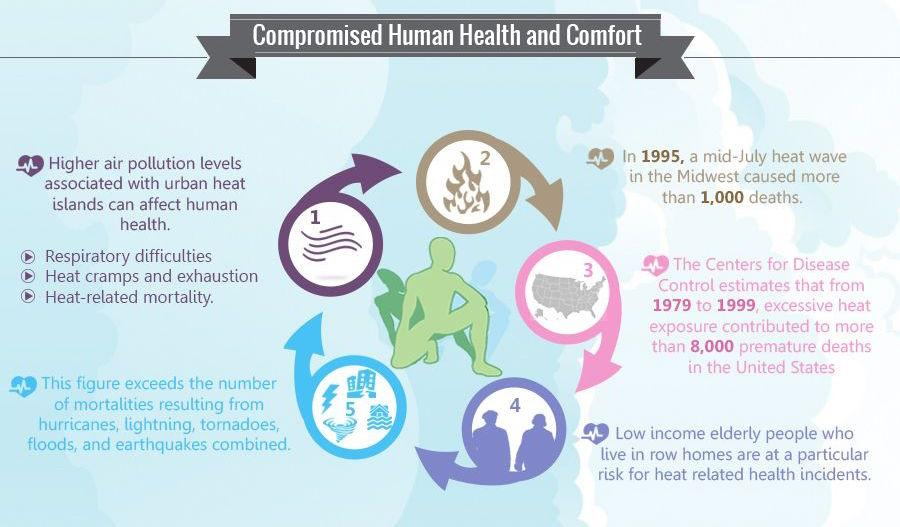List a handful of essential elements in this visual. Low-income elderly individuals who reside in row houses are at the greatest risk for developing health problems due to excessive heat. It is stated here that 5 points are mentioned. High air pollution levels in urban heat islands can cause a range of health problems, including respiratory difficulties, heat cramps and exhaustion, and an increased risk of heat-related mortality. Excessive heat exposure was the primary cause of premature deaths in the United States. In addition to heat-related mortalities, there are several other causes of mortality in the United States, including hurricanes, lightning, tornadoes, floods, and earthquakes. 